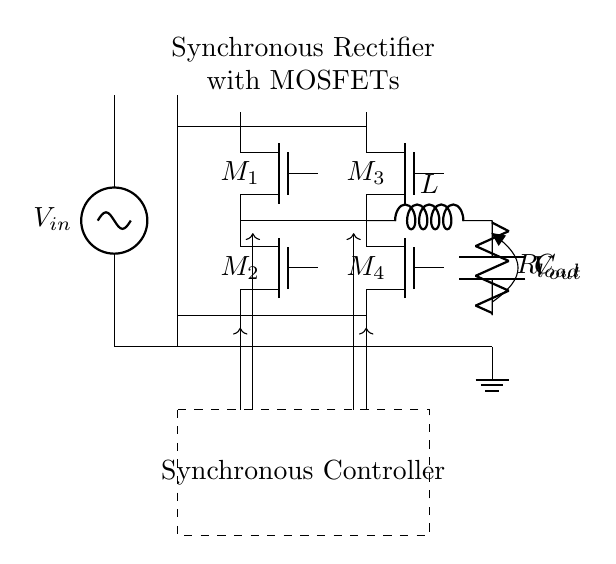What is the input voltage of the circuit? The input voltage is labeled as V_in, which is designated as the voltage supply at the beginning of the circuit.
Answer: V_in What type of components are M1, M2, M3, and M4? The components M1, M2, M3, and M4 are labeled as Tnmos, indicating they are N-channel MOSFETs used for rectification in the circuit.
Answer: N-channel MOSFETs What is the purpose of the inductor L in the output? The inductor L serves as a filter component in the output stage, smoothing the current by preventing sudden changes in current, commonly used in power supply circuits to reduce ripple.
Answer: Filter How are M1 and M2 connected to the transformer? M1 and M2 are connected in parallel to the output of the transformer; both switch simultaneously based on the synchronous control signals to rectify the alternating current to direct current.
Answer: Parallel What role does the synchronous controller play in this circuit? The synchronous controller orchestrates the switching conditions of the MOSFETs M1, M2, M3, and M4 to ensure efficient rectification, minimizing losses typically associated with diode rectifiers.
Answer: Control of MOSFETs How many phases does this synchronous rectifier handle? The circuit handles two phases; there are two pairs of MOSFETs (M1, M2) and (M3, M4), suggesting it can rectify both halves of the AC input waveform.
Answer: Two phases 